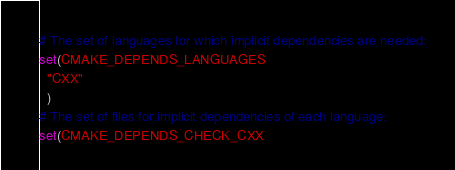Convert code to text. <code><loc_0><loc_0><loc_500><loc_500><_CMake_># The set of languages for which implicit dependencies are needed:
set(CMAKE_DEPENDS_LANGUAGES
  "CXX"
  )
# The set of files for implicit dependencies of each language:
set(CMAKE_DEPENDS_CHECK_CXX</code> 